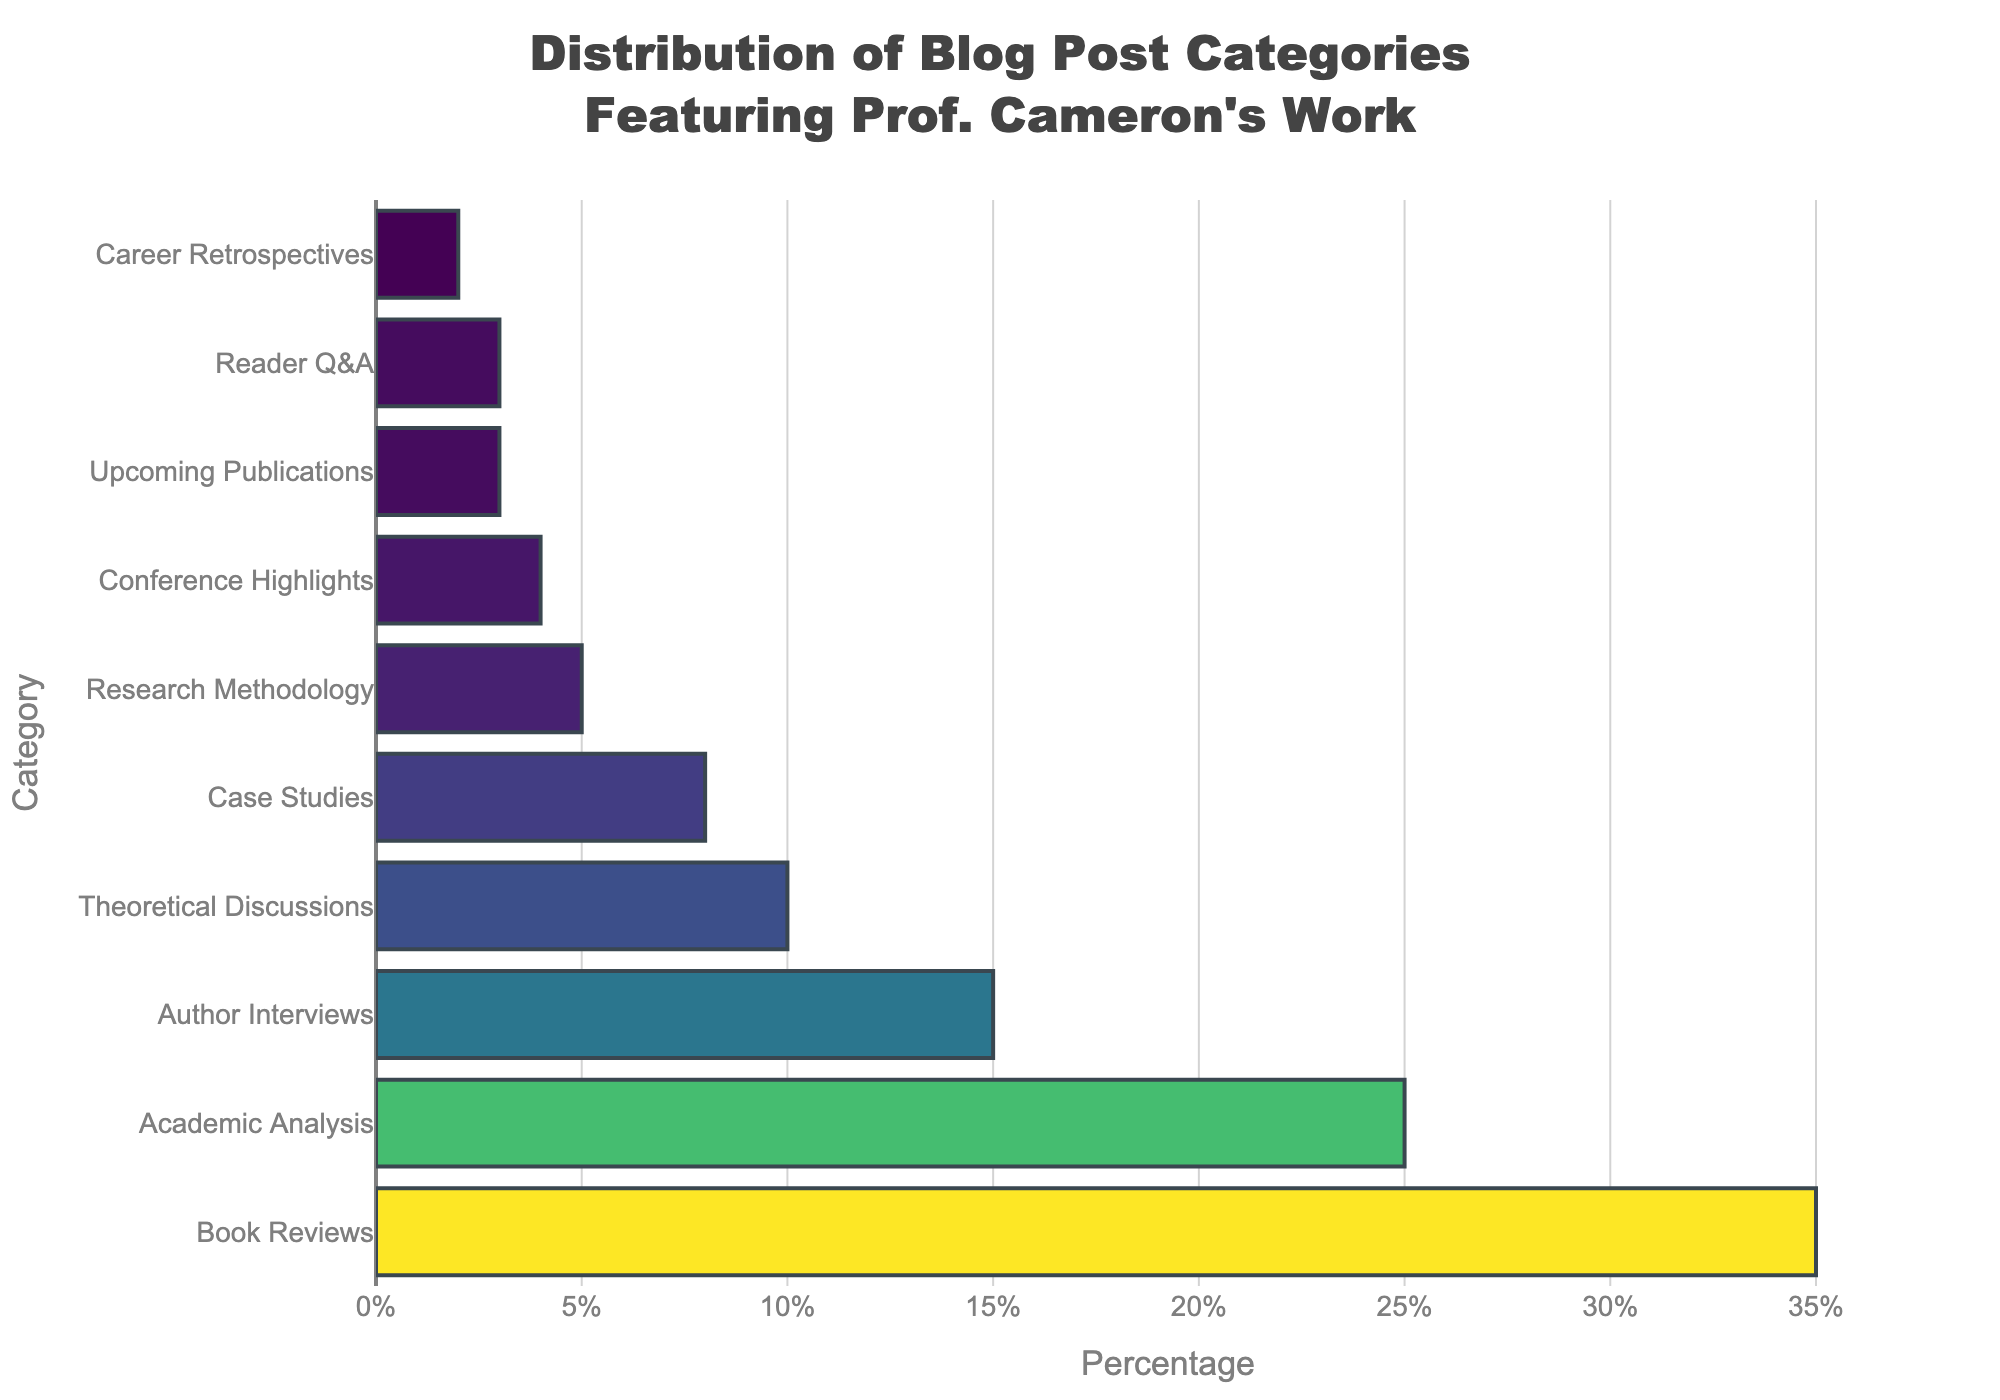What category is the most frequently featured for Prof. Cameron's work? The bar chart shows that "Book Reviews" has the highest percentage, indicated by the longest bar.
Answer: Book Reviews Which two categories combined make up 50% of the blog posts? Adding the percentages of "Book Reviews" (35%) and "Academic Analysis" (25%) gives a total of 60%, exceeding 50%. Instead, adding "Book Reviews" (35%) and "Author Interviews" (15%) results in 50%.
Answer: Book Reviews and Author Interviews How does the percentage of "Theoretical Discussions" compare to "Research Methodology"? "Theoretical Discussions" has 10%, while "Research Methodology" has 5%. The percentage for "Theoretical Discussions" is double that of "Research Methodology".
Answer: Theoretical Discussions is double Research Methodology What is the combined percentage of "Case Studies" and "Conference Highlights"? Summing up the percentages, "Case Studies" has 8% and "Conference Highlights" has 4%, giving a total of 8% + 4% = 12%.
Answer: 12% Given that the total percentage is 100%, which two categories together make up less than 10%? Adding "Career Retrospectives" (2%) and "Upcoming Publications" (3%) results in 5%, which is less than 10%. Another combination could be "Reader Q&A" (3%) and "Career Retrospectives" (2%), also resulting in 5%.
Answer: Career Retrospectives and Upcoming Publications or Reader Q&A Which category is represented by a bar of medium length among all categories? "Author Interviews" appears in the middle range with 15%, making it neither the longest nor the shortest bar.
Answer: Author Interviews What is the visual difference between the "Book Reviews" and the "Conference Highlights" bars? The "Book Reviews" bar is much longer and more prominently colored than the "Conference Highlights" bar, reflecting its significantly higher percentage of 35% versus 4%.
Answer: Book Reviews bar is much longer and prominent than Conference Highlights Is the percentage of "Academic Analysis" greater or less than the percentage of "Author Interviews"? The percentage of "Academic Analysis" is 25%, while "Author Interviews" is 15%. Therefore, "Academic Analysis" is greater than "Author Interviews".
Answer: Academic Analysis is greater Which category just exceeds the 5% threshold but is not among the top 3 categories? "Case Studies" exceeds the 5% threshold with 8%, and it is not among the top 3 categories (Book Reviews, Academic Analysis, Author Interviews).
Answer: Case Studies Do "Reader Q&A" and "Career Retrospectives" together meet the 5% mark? Adding "Reader Q&A" (3%) and "Career Retrospectives" (2%) makes a total of 5%, meeting the 5% mark exactly.
Answer: Yes 